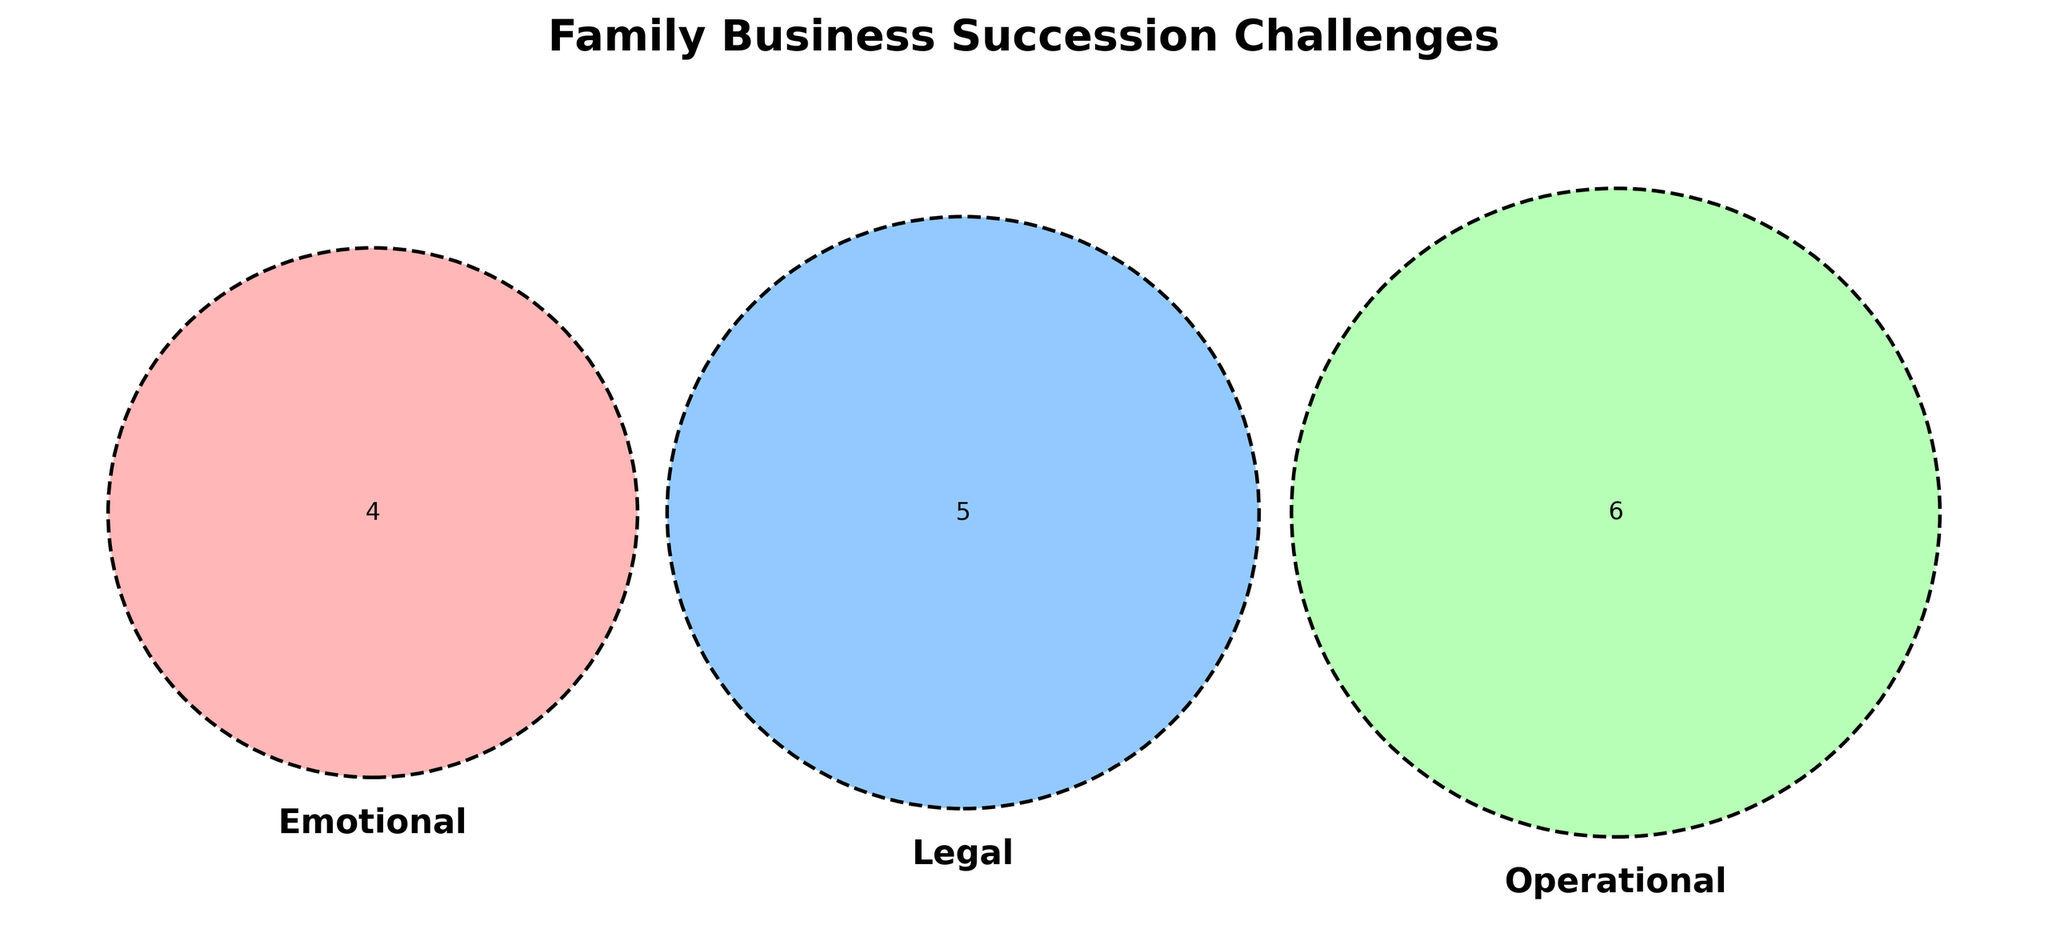What are the main challenges in the 'Emotional' category? The challenges listed under the 'Emotional' category can be directly read from the Venn diagram.
Answer: Family conflicts, Letting go, Sibling rivalry, Trust issues Which challenge occurs in all three categories: Emotional, Legal, and Operational? Observing the central overlapping area of all three circles in the Venn diagram will provide the answer.
Answer: None Are there any challenges uniquely identified in the 'Operational' category? By looking at the non-overlapping section of the 'Operational' circle, we can identify unique challenges.
Answer: Employee retention How many challenges are there in total across all categories? Count all unique challenges listed in the Venn diagram, ensuring no double-counting in overlapping regions.
Answer: 15 Which challenges overlap between 'Legal' and 'Operational'? Examine the Venn diagram for the overlapping area between the 'Legal' and 'Operational' circles.
Answer: Estate planning, Regulatory compliance What challenges overlap between 'Emotional' and 'Legal' categories? Look at the section where the 'Emotional' and 'Legal' circles overlap in the Venn diagram.
Answer: None How many challenges are shared between 'Emotional' and 'Operational'? The Venn diagram's overlapping area between 'Emotional' and 'Operational' circles will show this.
Answer: None What is the title of the diagram? The title is usually positioned at the top of the diagram and easy to read.
Answer: Family Business Succession Challenges What colors are used for the 'Emotional', 'Legal', and 'Operational' categories? By observing the Venn diagram, you can note the colors used for each circle representing the specific categories.
Answer: Red for Emotional, Blue for Legal, Green for Operational 